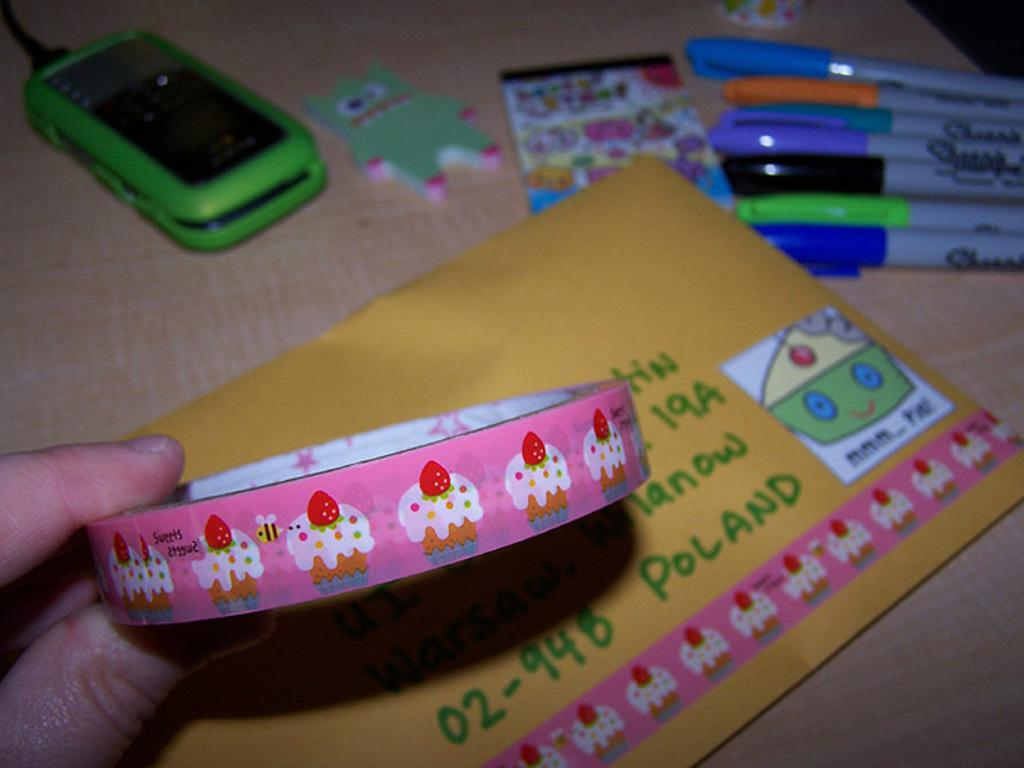<image>
Create a compact narrative representing the image presented. A hand holds pink tape with cupcakes on it over an envelope addressed to Poland on which a strip of the tape has been placed. 